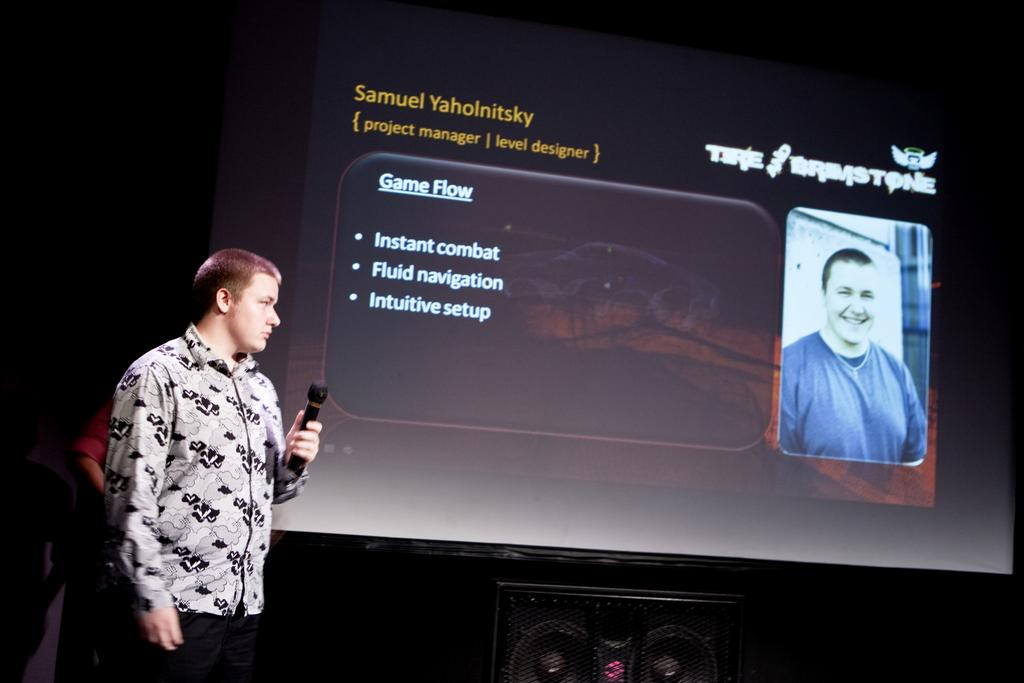What is the man in the image doing? The man is standing in front of a screen. What is on the screen? The screen displays a photo of a person. What object is the man holding? The man is holding a guitar. What other item is present under the screen? There is a speaker under the screen. What type of square can be seen in the image? There is no square present in the image. What view is visible in the photo on the screen? The photo on the screen is not described in detail, so it is not possible to determine the view. 